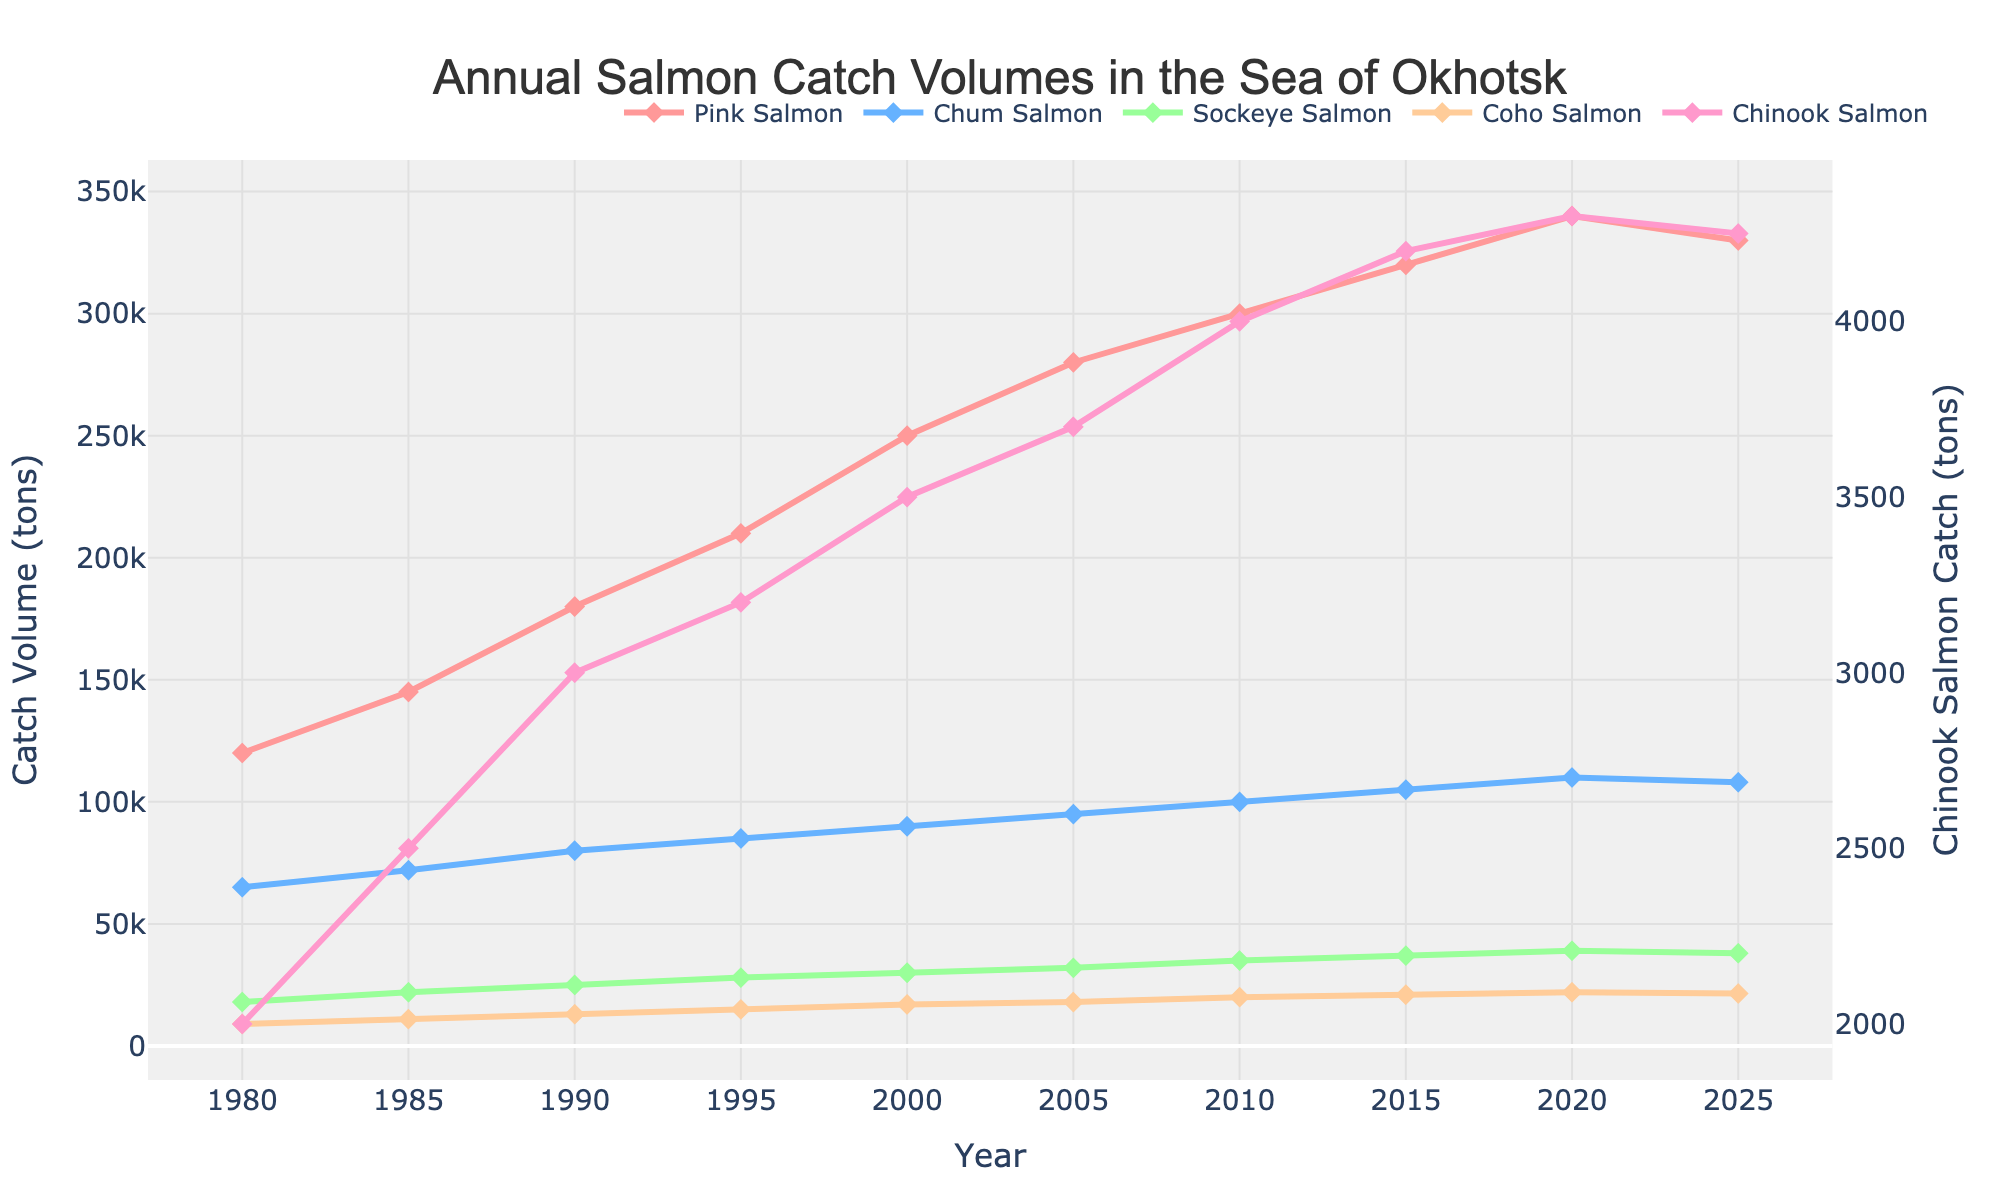Which salmon species has the highest catch volume in 2025? The figure shows the annual salmon catch volumes categorized by species. In 2025, the peak value belongs to Pink Salmon.
Answer: Pink Salmon What is the catch volume difference between Pink Salmon and Chum Salmon in 1990? To determine this, locate the catch volumes for Pink Salmon (180,000 tons) and Chum Salmon (80,000 tons) in 1990. The difference is calculated as 180,000 - 80,000 = 100,000 tons.
Answer: 100,000 tons Which year showed the maximum catch volume for Sockeye Salmon? Check the Sockeye Salmon line across different years. The highest value appears at the year 2020, which is 39,000 tons.
Answer: 2020 How much did the catch volume for Coho Salmon increase from 1985 to 2000? Check the Coho Salmon catch volumes in 1985 (11,000 tons) and 2000 (17,000 tons). The increase over this period is calculated as 17,000 - 11,000 = 6,000 tons.
Answer: 6,000 tons Which salmon species consistently had the lowest catch volumes across the years? By examining all the salmon categories, Chinook Salmon appears to have the lowest catch volumes every year.
Answer: Chinook Salmon Compare the catch volumes of Chum Salmon and Coho Salmon in 2015. Which is higher and by how much? Locate 2015 for Chum Salmon (105,000 tons) and Coho Salmon (21,000 tons). Chum Salmon is higher; the difference is 105,000 - 21,000 = 84,000 tons.
Answer: Chum Salmon by 84,000 tons What trends can you observe for Pink Salmon and Chinook Salmon between 1980 and 2020? Pink Salmon shows a steady upward trend from 120,000 tons in 1980 to 340,000 tons in 2020. Meanwhile, Chinook Salmon sees a gradual increase from 2,000 tons in 1980 to 4,300 tons in 2020.
Answer: Upward trend for both What is the average catch volume of Coho Salmon for the years 2000, 2005, and 2010? Check the volumes for Coho Salmon in 2000 (17,000 tons), 2005 (18,000 tons), and 2010 (20,000 tons). Calculate the average as (17,000 + 18,000 + 20,000) / 3 = 18,333.33 tons.
Answer: 18,333.33 tons Is there a year when the catch volumes of Sockeye Salmon and Coho Salmon are equal? Examine both lines for overlap. There is no point where Sockeye Salmon and Coho Salmon values match exactly.
Answer: No What is the percentage increase in the catch volume of Chinook Salmon from 1980 to 2010? Find values for Chinook Salmon in 1980 (2,000 tons) and 2010 (4,000 tons). The percentage increase is ((4,000 - 2,000) / 2,000) * 100 = 100%.
Answer: 100% 